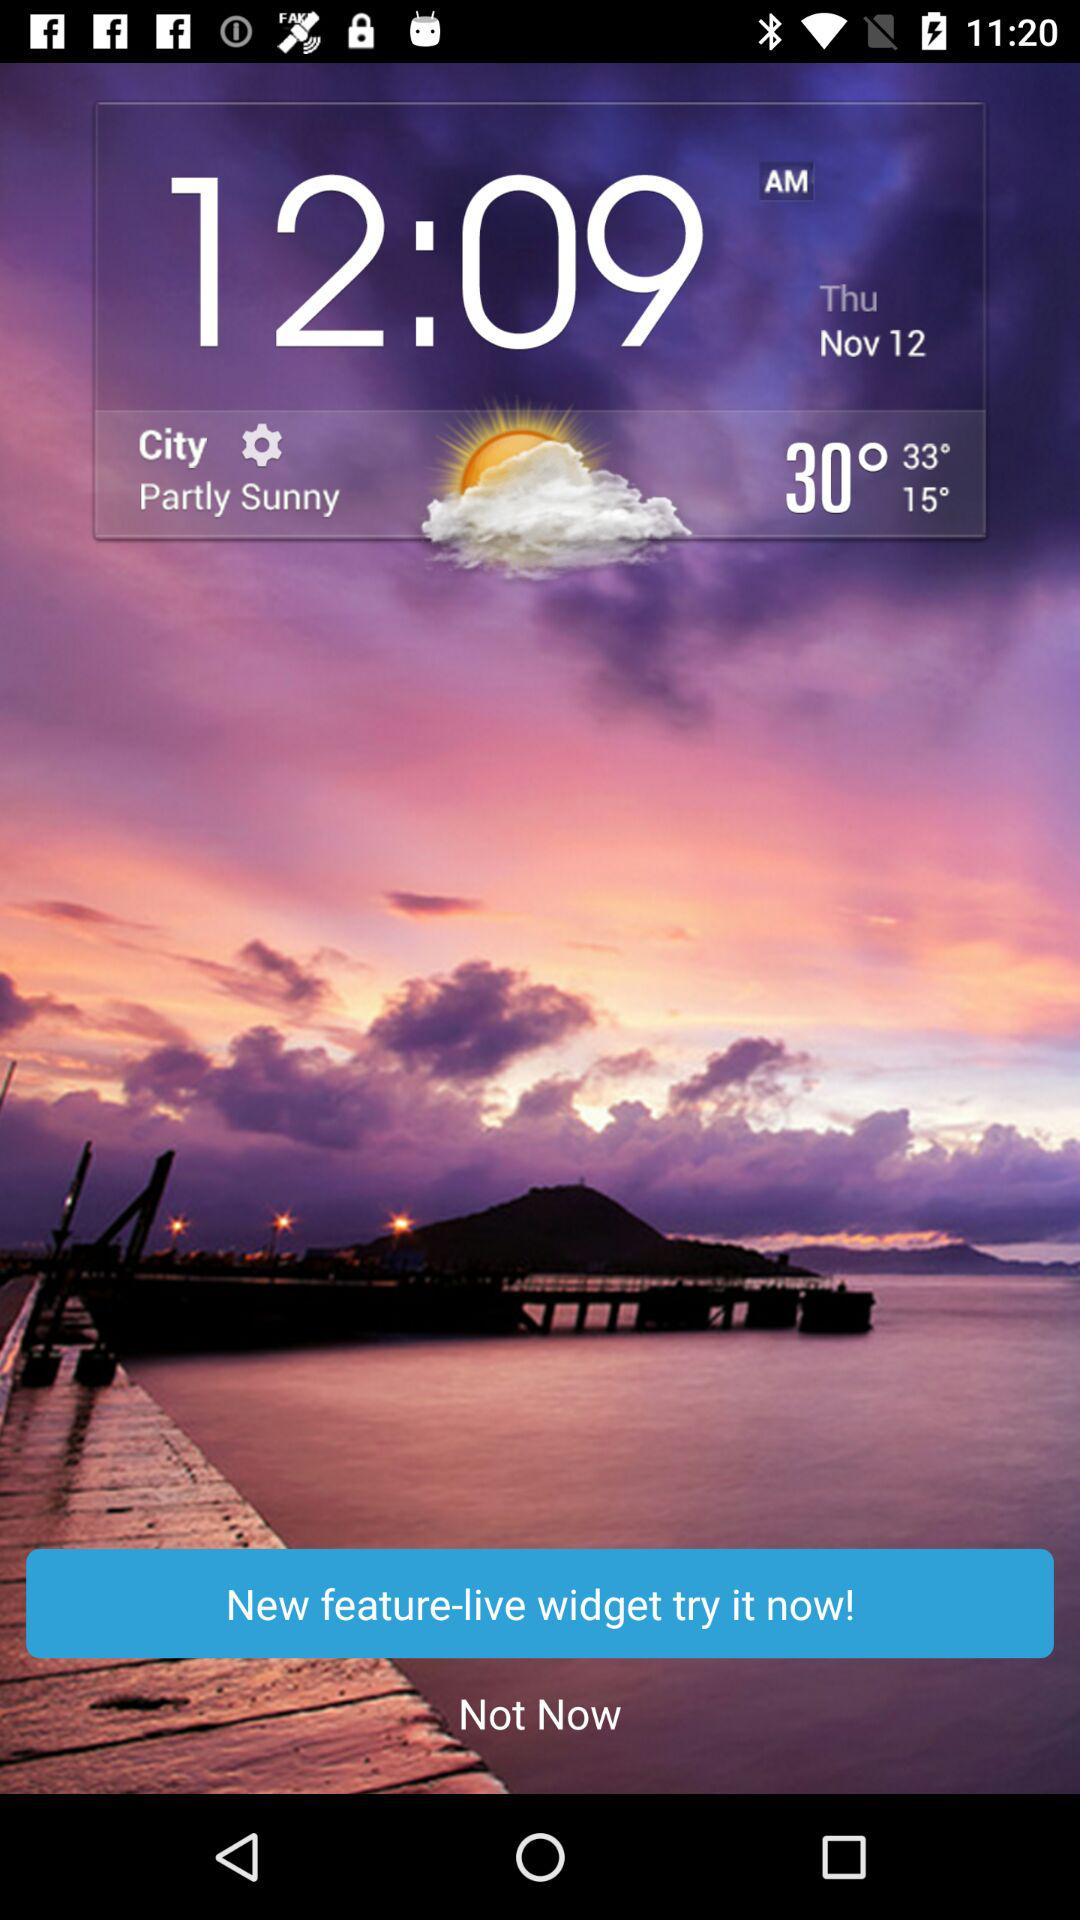What's the weather like on Thursday, November 12? The weather is "Partly Sunny". 